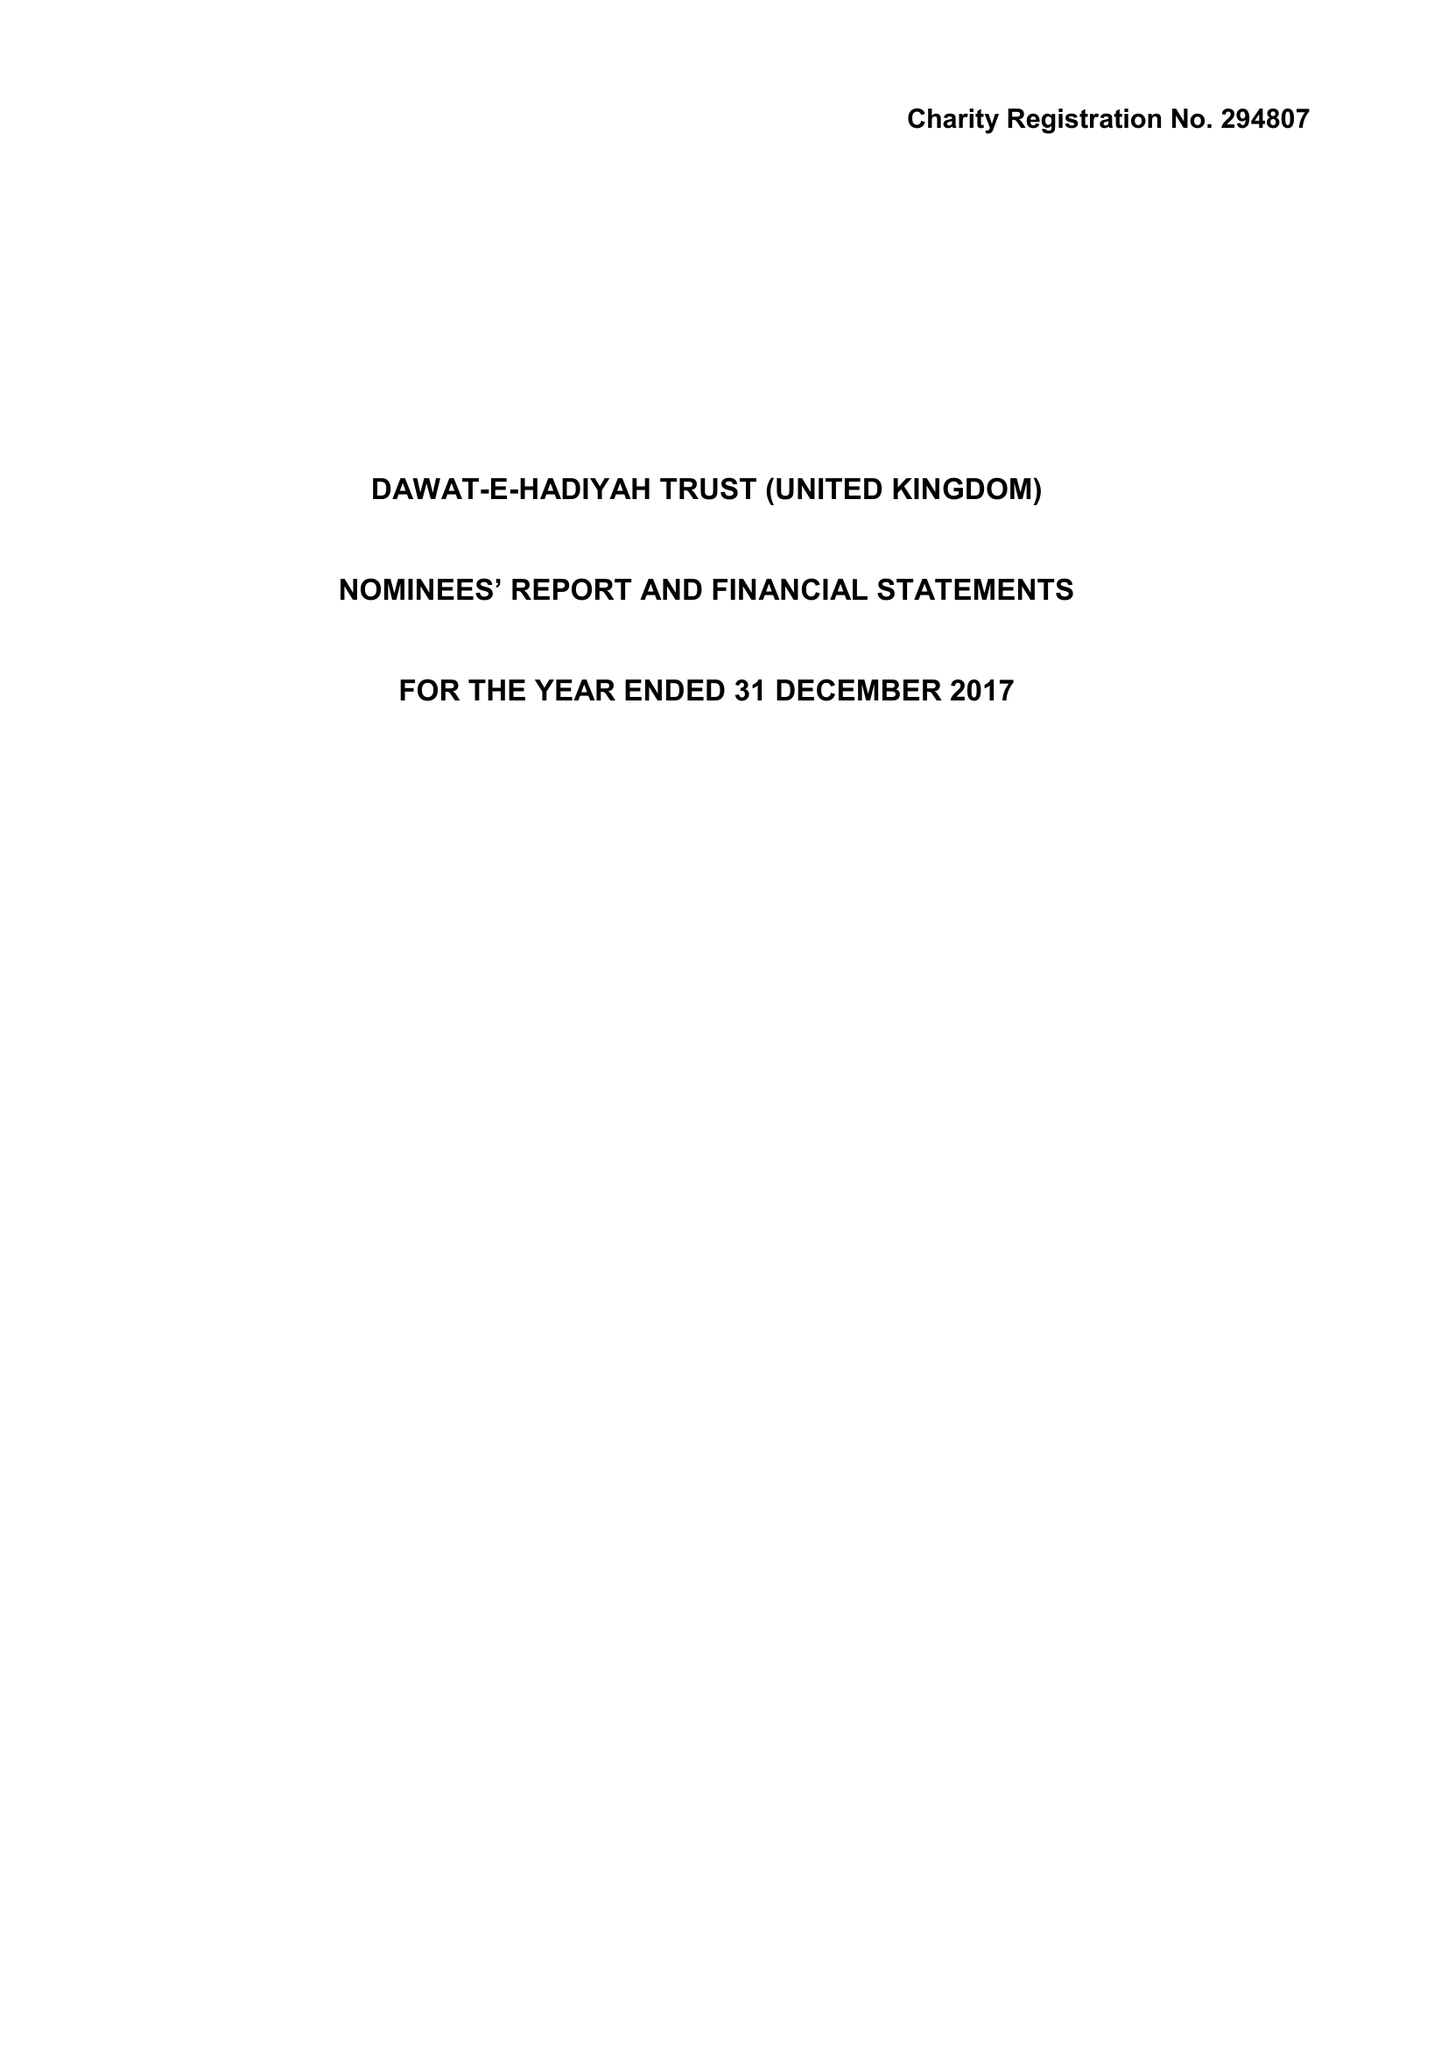What is the value for the income_annually_in_british_pounds?
Answer the question using a single word or phrase. 36308084.00 